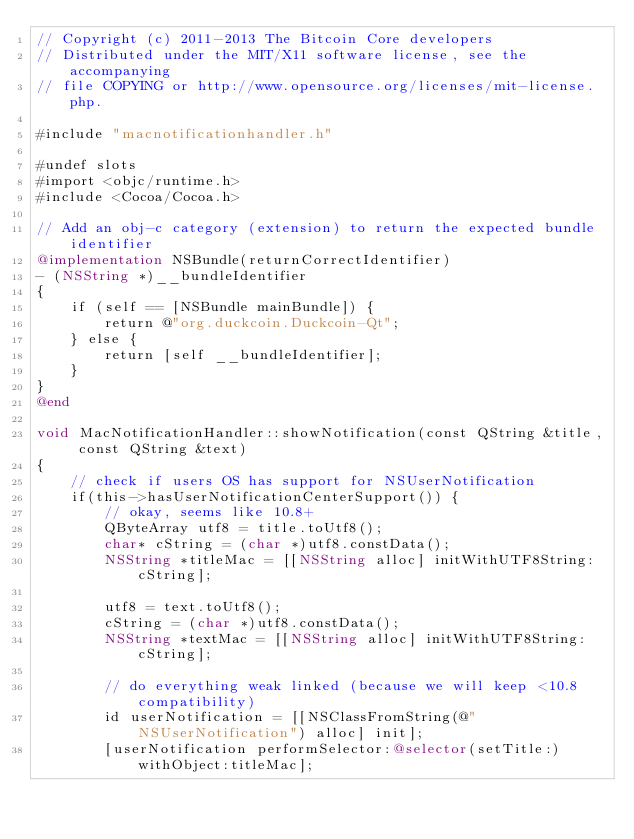Convert code to text. <code><loc_0><loc_0><loc_500><loc_500><_ObjectiveC_>// Copyright (c) 2011-2013 The Bitcoin Core developers
// Distributed under the MIT/X11 software license, see the accompanying
// file COPYING or http://www.opensource.org/licenses/mit-license.php.

#include "macnotificationhandler.h"

#undef slots
#import <objc/runtime.h>
#include <Cocoa/Cocoa.h>

// Add an obj-c category (extension) to return the expected bundle identifier
@implementation NSBundle(returnCorrectIdentifier)
- (NSString *)__bundleIdentifier
{
    if (self == [NSBundle mainBundle]) {
        return @"org.duckcoin.Duckcoin-Qt";
    } else {
        return [self __bundleIdentifier];
    }
}
@end

void MacNotificationHandler::showNotification(const QString &title, const QString &text)
{
    // check if users OS has support for NSUserNotification
    if(this->hasUserNotificationCenterSupport()) {
        // okay, seems like 10.8+
        QByteArray utf8 = title.toUtf8();
        char* cString = (char *)utf8.constData();
        NSString *titleMac = [[NSString alloc] initWithUTF8String:cString];

        utf8 = text.toUtf8();
        cString = (char *)utf8.constData();
        NSString *textMac = [[NSString alloc] initWithUTF8String:cString];

        // do everything weak linked (because we will keep <10.8 compatibility)
        id userNotification = [[NSClassFromString(@"NSUserNotification") alloc] init];
        [userNotification performSelector:@selector(setTitle:) withObject:titleMac];</code> 